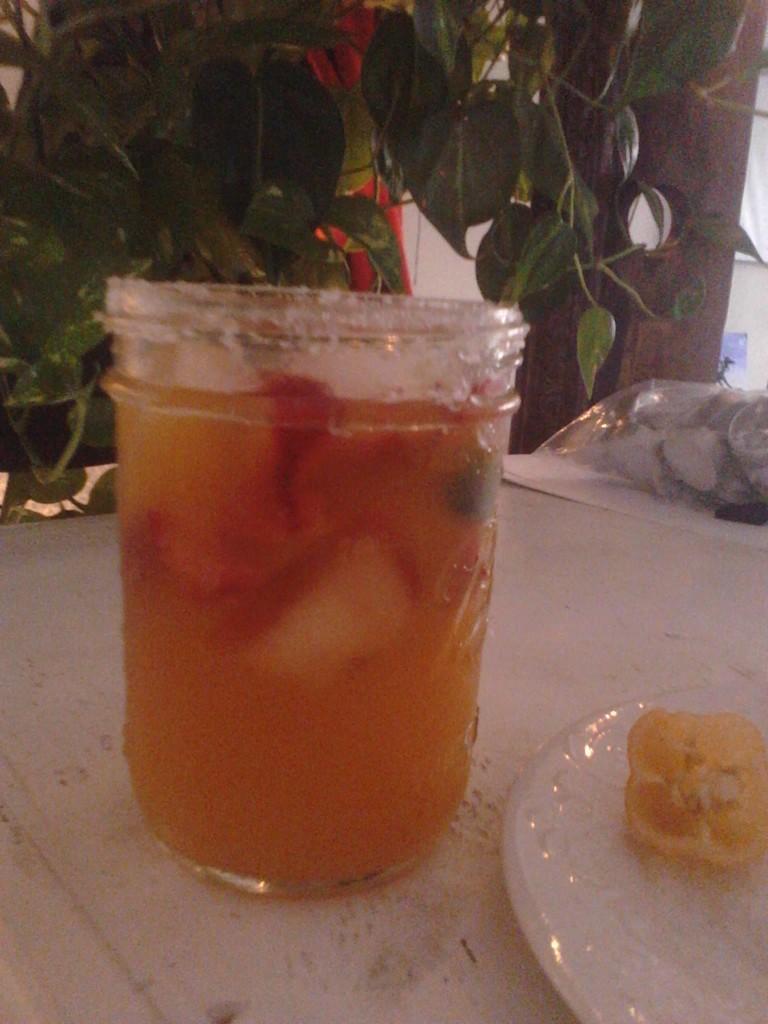In one or two sentences, can you explain what this image depicts? In this image we can see a glass is kept on the white surface. Bottom right of the image one white color plate is present and in it some food is there. Background of the image plant is present. Right side of the image one plastic cover is there. 